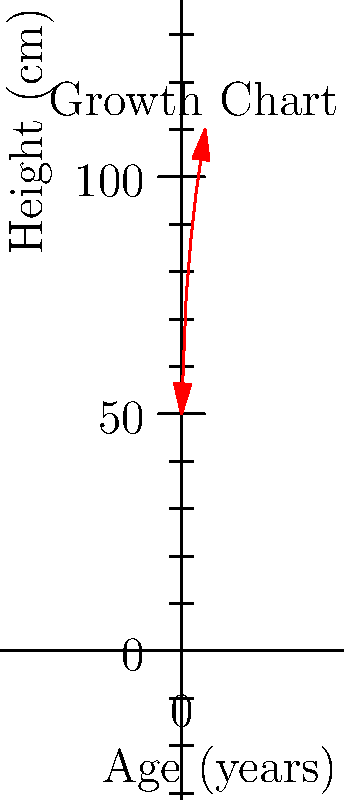As a father tracking your child's growth, you plot their height against age on a chart. The resulting curve resembles a vector function. If the rate of change in height between ages 2 and 3 is represented by the vector $\vec{v}$, what would be the magnitude of $2\vec{v}$ in cm/year? To solve this problem, let's follow these steps:

1. Identify the heights at ages 2 and 3:
   At age 2: 87 cm
   At age 3: 96 cm

2. Calculate the change in height:
   $\Delta h = 96 \text{ cm} - 87 \text{ cm} = 9 \text{ cm}$

3. Calculate the rate of change (magnitude of $\vec{v}$):
   $|\vec{v}| = \frac{\Delta h}{\Delta t} = \frac{9 \text{ cm}}{1 \text{ year}} = 9 \text{ cm/year}$

4. Calculate the magnitude of $2\vec{v}$:
   $|2\vec{v}| = 2 \times |\vec{v}| = 2 \times 9 \text{ cm/year} = 18 \text{ cm/year}$

Therefore, the magnitude of $2\vec{v}$ is 18 cm/year.
Answer: 18 cm/year 